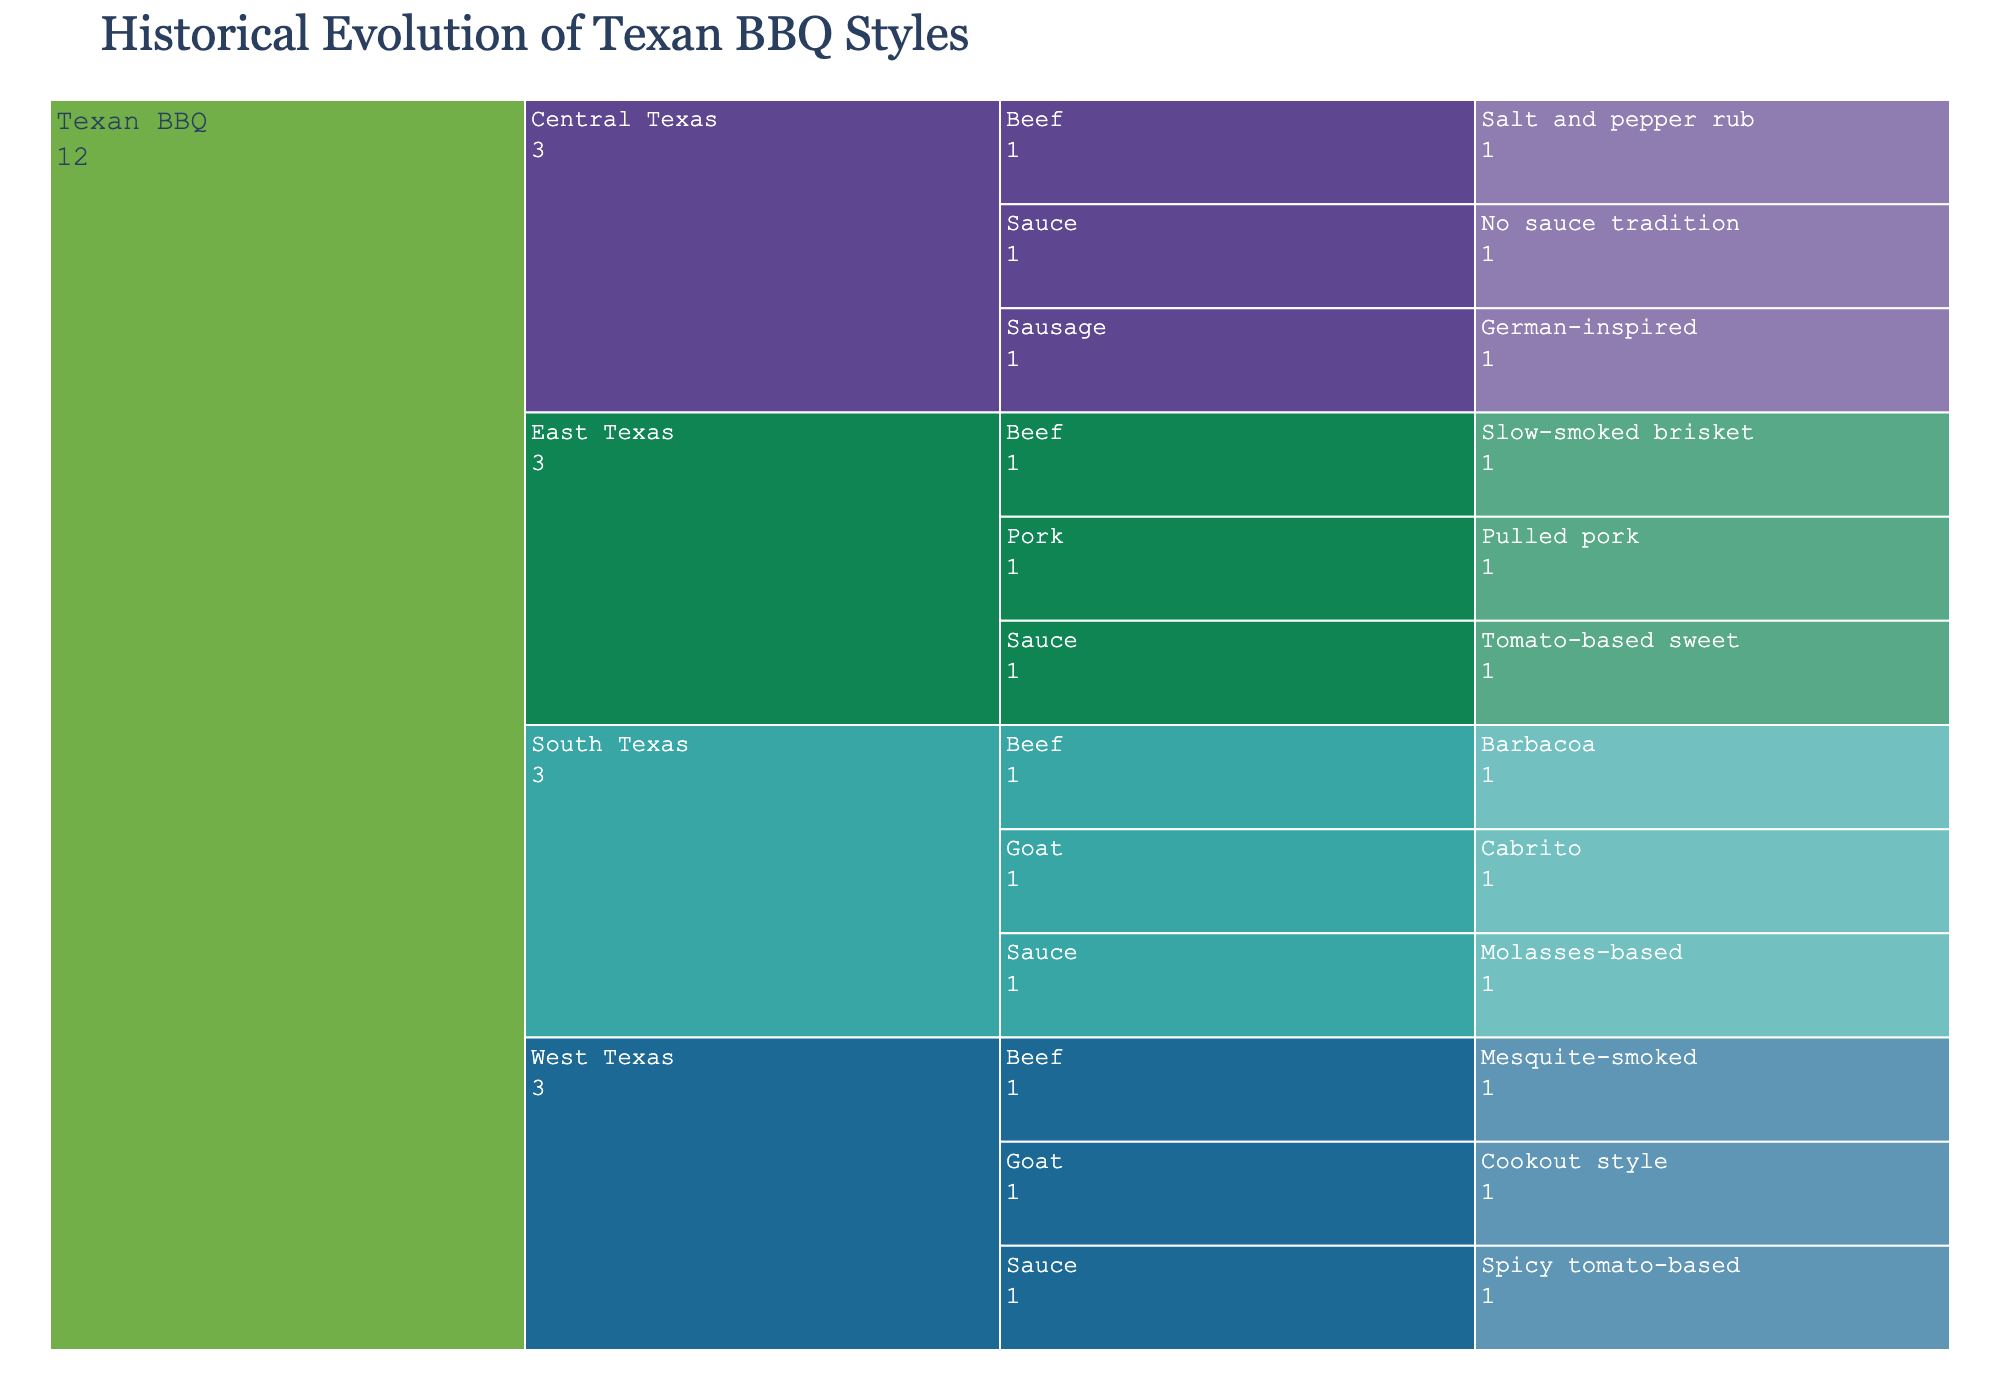what is the title of the Icicle Chart? The title is typically displayed at the top of the chart and reflects the main topic it represents. Observing the figure, the title reads 'Historical Evolution of Texan BBQ Styles'.
Answer: Historical Evolution of Texan BBQ Styles How many main categories of Texan BBQ styles are there? The main categories can be identified as the primary branches stemming from the root node labeled 'Texan BBQ'. Based on the chart, there are four main categories.
Answer: Four Which category represents the traditional Cabrito style? Look for the label 'Cabrito' in the chart. It is a subcategory under 'South Texas'.
Answer: South Texas Is there a sauce tradition in Central Texas BBQ? The chart displays specific types of sauces associated with various regions. In Central Texas, there is no tradition of sauce, as indicated by the 'No sauce tradition' label.
Answer: No Which category has the most diverse styles of beef BBQ? The question requires the identification of all categories that have beef BBQ styles and then determining which category has the most distinct styles. East Texas has one, Central Texas has one, South Texas has one, and West Texas has one, so there is no one category with more diversity in this case.
Answer: They are equally diverse What type of sauce is used in East Texas BBQ? Look under the 'Sauce' subcategories stemming from the 'East Texas' branch. The specific type of sauce used in East Texas BBQ is 'Tomato-based sweet'.
Answer: Tomato-based sweet Compare the styles of BBQ for goat found in South Texas and West Texas. Identifying the branches for goat BBQ in 'South Texas' and 'West Texas', South Texas has 'Cabrito' and West Texas has 'Cookout style'. Both indicate a method or cultural influence in cooking goat meat.
Answer: South Texas: Cabrito, West Texas: Cookout style How many different styles of sausage BBQ are represented in the chart? Trace the branches from the root 'Texan BBQ' to identify where sausage BBQ is listed. It's only found under the 'Central Texas' category, labeled as 'German-inspired'.
Answer: One Which category uses a Molasses-based sauce? By checking the sauce types under each region, the 'South Texas' branch shows a 'Molasses-based' sauce.
Answer: South Texas Compare the influence of German culture on the BBQ styles represented in the chart. 'German-inspired' sausage can be found under the 'Central Texas' category. No other regions indicate a German influence, suggesting it is unique to Central Texas.
Answer: Only Central Texas 